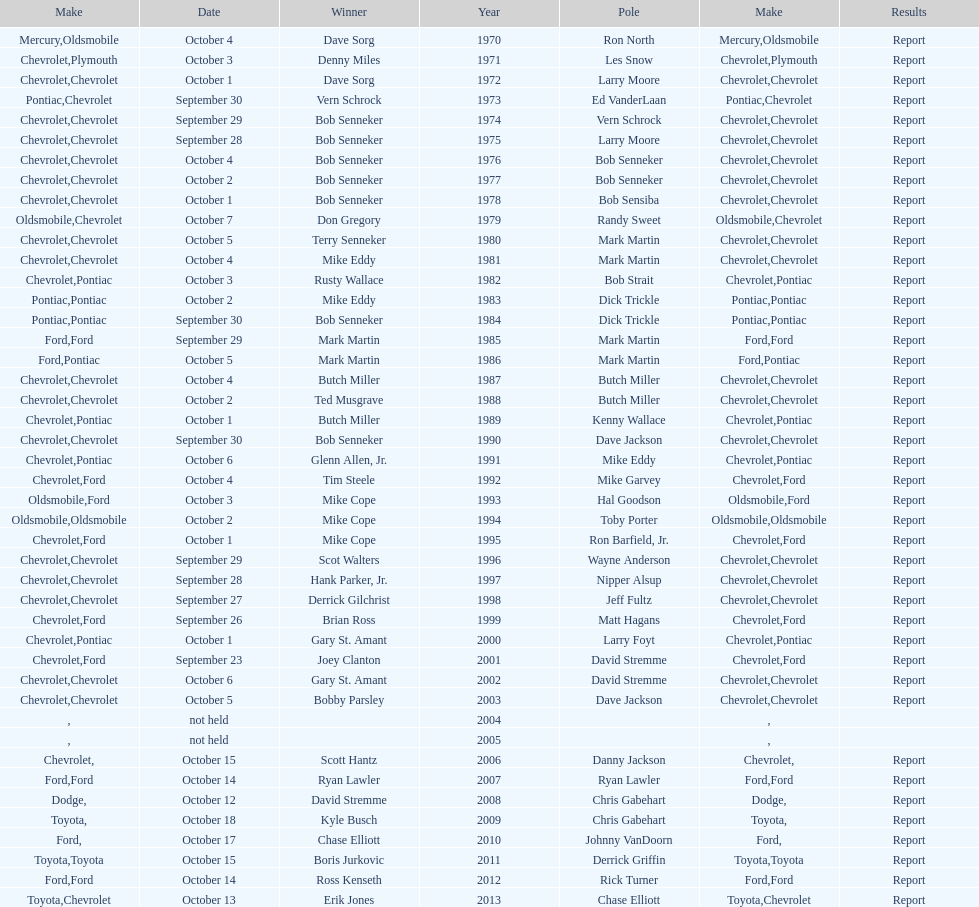Could you help me parse every detail presented in this table? {'header': ['Make', 'Date', 'Winner', 'Year', 'Pole', 'Make', 'Results'], 'rows': [['Mercury', 'October 4', 'Dave Sorg', '1970', 'Ron North', 'Oldsmobile', 'Report'], ['Chevrolet', 'October 3', 'Denny Miles', '1971', 'Les Snow', 'Plymouth', 'Report'], ['Chevrolet', 'October 1', 'Dave Sorg', '1972', 'Larry Moore', 'Chevrolet', 'Report'], ['Pontiac', 'September 30', 'Vern Schrock', '1973', 'Ed VanderLaan', 'Chevrolet', 'Report'], ['Chevrolet', 'September 29', 'Bob Senneker', '1974', 'Vern Schrock', 'Chevrolet', 'Report'], ['Chevrolet', 'September 28', 'Bob Senneker', '1975', 'Larry Moore', 'Chevrolet', 'Report'], ['Chevrolet', 'October 4', 'Bob Senneker', '1976', 'Bob Senneker', 'Chevrolet', 'Report'], ['Chevrolet', 'October 2', 'Bob Senneker', '1977', 'Bob Senneker', 'Chevrolet', 'Report'], ['Chevrolet', 'October 1', 'Bob Senneker', '1978', 'Bob Sensiba', 'Chevrolet', 'Report'], ['Oldsmobile', 'October 7', 'Don Gregory', '1979', 'Randy Sweet', 'Chevrolet', 'Report'], ['Chevrolet', 'October 5', 'Terry Senneker', '1980', 'Mark Martin', 'Chevrolet', 'Report'], ['Chevrolet', 'October 4', 'Mike Eddy', '1981', 'Mark Martin', 'Chevrolet', 'Report'], ['Chevrolet', 'October 3', 'Rusty Wallace', '1982', 'Bob Strait', 'Pontiac', 'Report'], ['Pontiac', 'October 2', 'Mike Eddy', '1983', 'Dick Trickle', 'Pontiac', 'Report'], ['Pontiac', 'September 30', 'Bob Senneker', '1984', 'Dick Trickle', 'Pontiac', 'Report'], ['Ford', 'September 29', 'Mark Martin', '1985', 'Mark Martin', 'Ford', 'Report'], ['Ford', 'October 5', 'Mark Martin', '1986', 'Mark Martin', 'Pontiac', 'Report'], ['Chevrolet', 'October 4', 'Butch Miller', '1987', 'Butch Miller', 'Chevrolet', 'Report'], ['Chevrolet', 'October 2', 'Ted Musgrave', '1988', 'Butch Miller', 'Chevrolet', 'Report'], ['Chevrolet', 'October 1', 'Butch Miller', '1989', 'Kenny Wallace', 'Pontiac', 'Report'], ['Chevrolet', 'September 30', 'Bob Senneker', '1990', 'Dave Jackson', 'Chevrolet', 'Report'], ['Chevrolet', 'October 6', 'Glenn Allen, Jr.', '1991', 'Mike Eddy', 'Pontiac', 'Report'], ['Chevrolet', 'October 4', 'Tim Steele', '1992', 'Mike Garvey', 'Ford', 'Report'], ['Oldsmobile', 'October 3', 'Mike Cope', '1993', 'Hal Goodson', 'Ford', 'Report'], ['Oldsmobile', 'October 2', 'Mike Cope', '1994', 'Toby Porter', 'Oldsmobile', 'Report'], ['Chevrolet', 'October 1', 'Mike Cope', '1995', 'Ron Barfield, Jr.', 'Ford', 'Report'], ['Chevrolet', 'September 29', 'Scot Walters', '1996', 'Wayne Anderson', 'Chevrolet', 'Report'], ['Chevrolet', 'September 28', 'Hank Parker, Jr.', '1997', 'Nipper Alsup', 'Chevrolet', 'Report'], ['Chevrolet', 'September 27', 'Derrick Gilchrist', '1998', 'Jeff Fultz', 'Chevrolet', 'Report'], ['Chevrolet', 'September 26', 'Brian Ross', '1999', 'Matt Hagans', 'Ford', 'Report'], ['Chevrolet', 'October 1', 'Gary St. Amant', '2000', 'Larry Foyt', 'Pontiac', 'Report'], ['Chevrolet', 'September 23', 'Joey Clanton', '2001', 'David Stremme', 'Ford', 'Report'], ['Chevrolet', 'October 6', 'Gary St. Amant', '2002', 'David Stremme', 'Chevrolet', 'Report'], ['Chevrolet', 'October 5', 'Bobby Parsley', '2003', 'Dave Jackson', 'Chevrolet', 'Report'], ['', 'not held', '', '2004', '', '', ''], ['', 'not held', '', '2005', '', '', ''], ['Chevrolet', 'October 15', 'Scott Hantz', '2006', 'Danny Jackson', '', 'Report'], ['Ford', 'October 14', 'Ryan Lawler', '2007', 'Ryan Lawler', 'Ford', 'Report'], ['Dodge', 'October 12', 'David Stremme', '2008', 'Chris Gabehart', '', 'Report'], ['Toyota', 'October 18', 'Kyle Busch', '2009', 'Chris Gabehart', '', 'Report'], ['Ford', 'October 17', 'Chase Elliott', '2010', 'Johnny VanDoorn', '', 'Report'], ['Toyota', 'October 15', 'Boris Jurkovic', '2011', 'Derrick Griffin', 'Toyota', 'Report'], ['Ford', 'October 14', 'Ross Kenseth', '2012', 'Rick Turner', 'Ford', 'Report'], ['Toyota', 'October 13', 'Erik Jones', '2013', 'Chase Elliott', 'Chevrolet', 'Report']]} How many winning oldsmobile vehicles made the list? 3. 